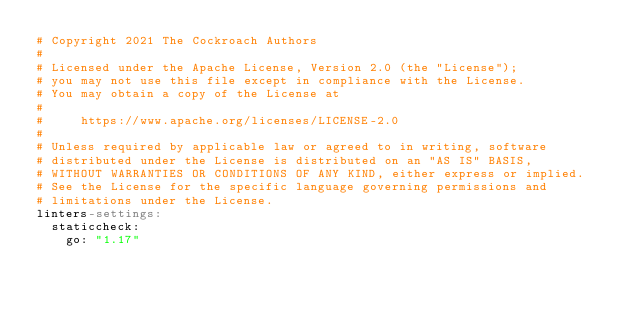<code> <loc_0><loc_0><loc_500><loc_500><_YAML_># Copyright 2021 The Cockroach Authors
#
# Licensed under the Apache License, Version 2.0 (the "License");
# you may not use this file except in compliance with the License.
# You may obtain a copy of the License at
#
#     https://www.apache.org/licenses/LICENSE-2.0
#
# Unless required by applicable law or agreed to in writing, software
# distributed under the License is distributed on an "AS IS" BASIS,
# WITHOUT WARRANTIES OR CONDITIONS OF ANY KIND, either express or implied.
# See the License for the specific language governing permissions and
# limitations under the License.
linters-settings:
  staticcheck:
    go: "1.17"
</code> 